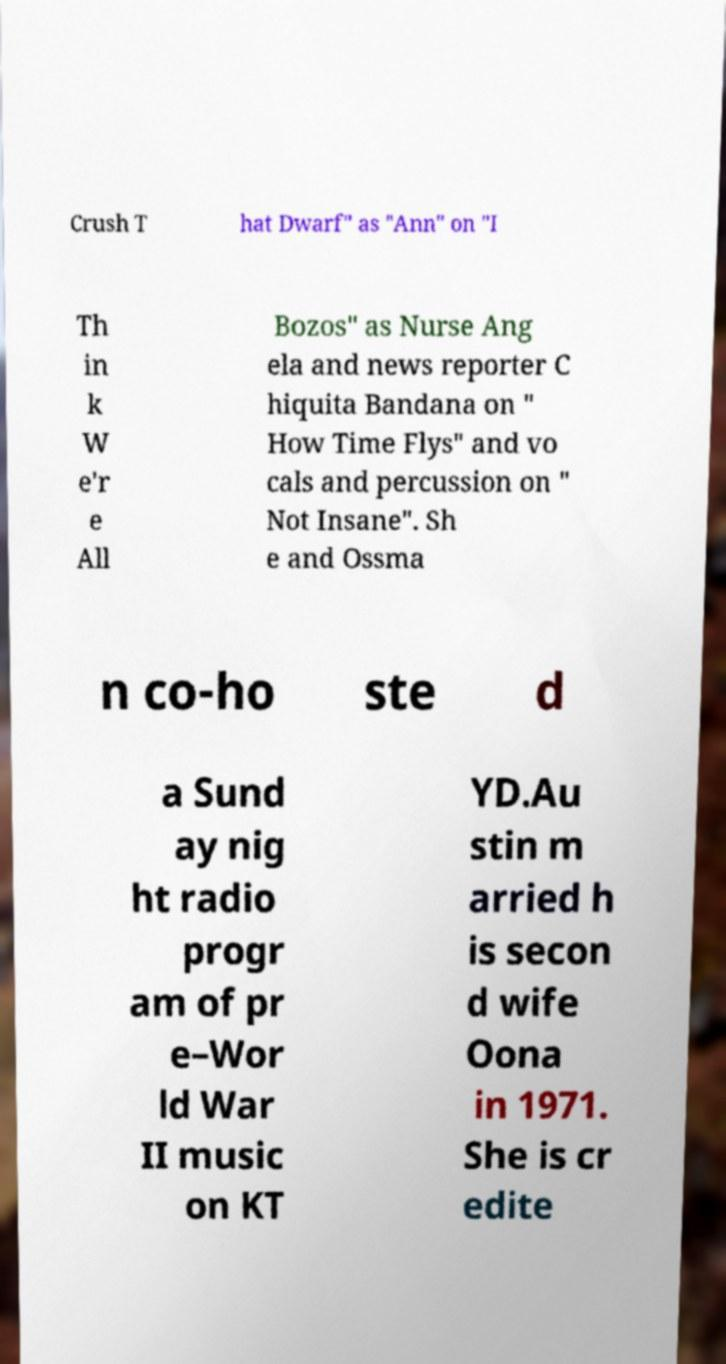Please identify and transcribe the text found in this image. Crush T hat Dwarf" as "Ann" on "I Th in k W e'r e All Bozos" as Nurse Ang ela and news reporter C hiquita Bandana on " How Time Flys" and vo cals and percussion on " Not Insane". Sh e and Ossma n co-ho ste d a Sund ay nig ht radio progr am of pr e–Wor ld War II music on KT YD.Au stin m arried h is secon d wife Oona in 1971. She is cr edite 